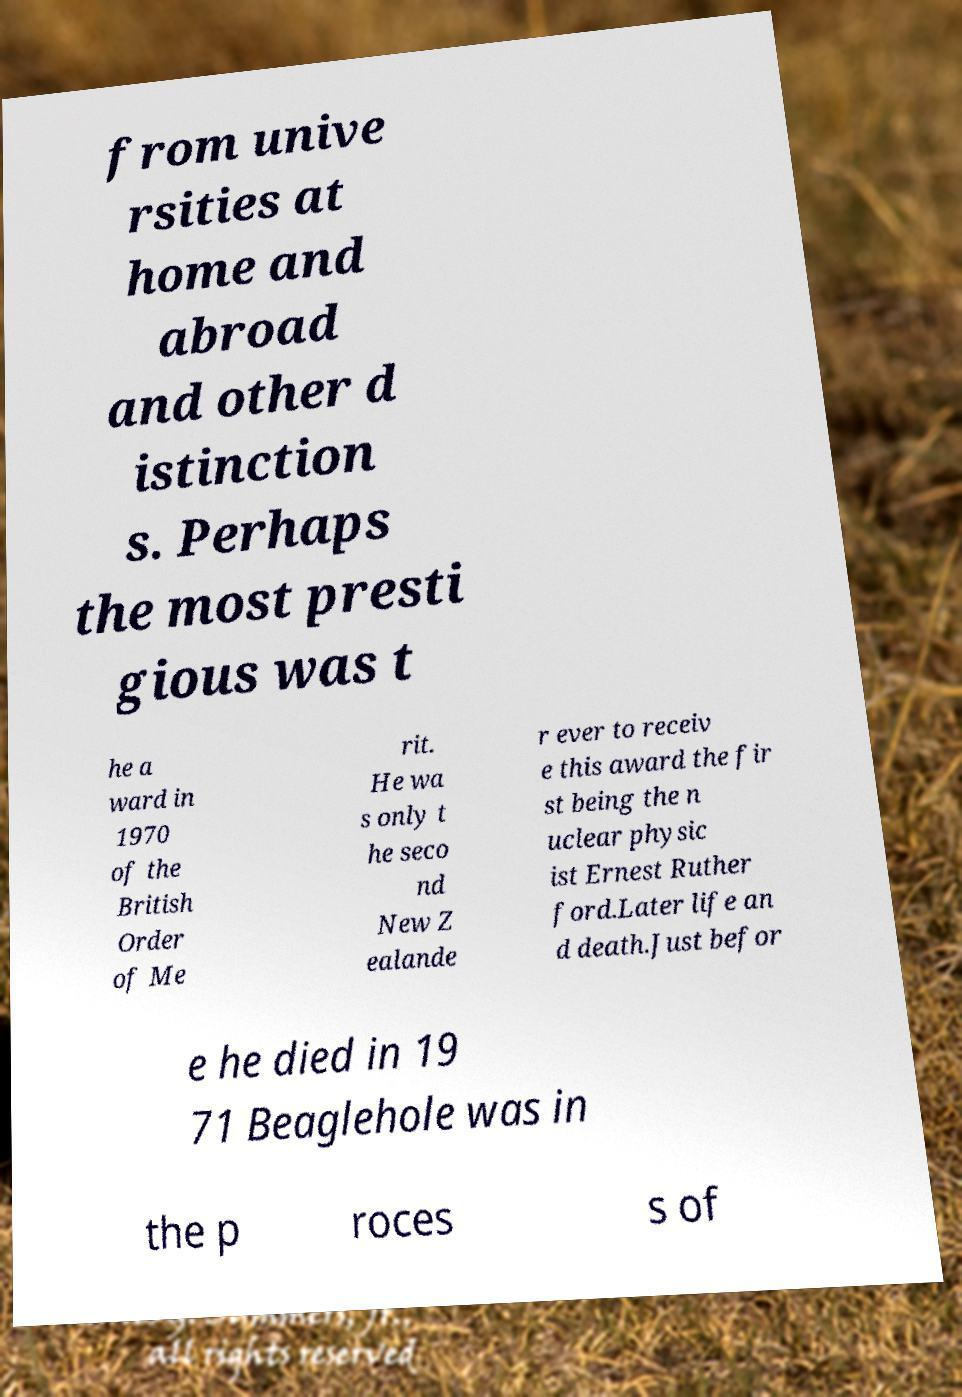For documentation purposes, I need the text within this image transcribed. Could you provide that? from unive rsities at home and abroad and other d istinction s. Perhaps the most presti gious was t he a ward in 1970 of the British Order of Me rit. He wa s only t he seco nd New Z ealande r ever to receiv e this award the fir st being the n uclear physic ist Ernest Ruther ford.Later life an d death.Just befor e he died in 19 71 Beaglehole was in the p roces s of 